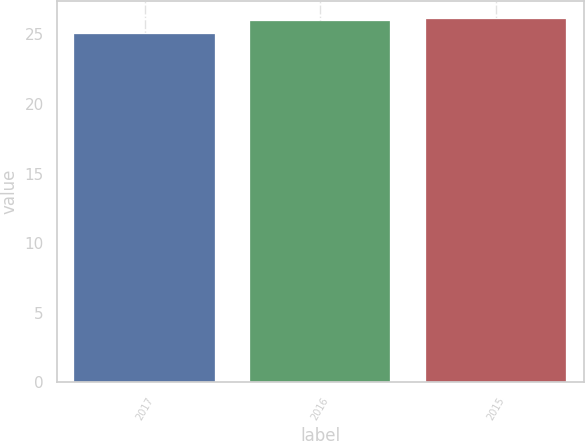<chart> <loc_0><loc_0><loc_500><loc_500><bar_chart><fcel>2017<fcel>2016<fcel>2015<nl><fcel>25<fcel>26<fcel>26.1<nl></chart> 